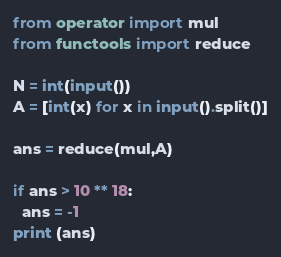Convert code to text. <code><loc_0><loc_0><loc_500><loc_500><_Python_>from operator import mul
from functools import reduce

N = int(input())
A = [int(x) for x in input().split()]

ans = reduce(mul,A)

if ans > 10 ** 18:
  ans = -1
print (ans)</code> 